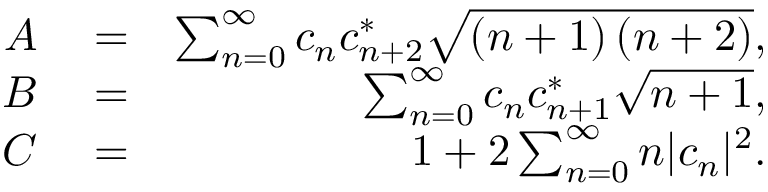<formula> <loc_0><loc_0><loc_500><loc_500>\begin{array} { r l r } { A } & = } & { \sum _ { n = 0 } ^ { \infty } c _ { n } c _ { n + 2 } ^ { * } \sqrt { \left ( n + 1 \right ) \left ( n + 2 \right ) } , } \\ { B } & = } & { \sum _ { n = 0 } ^ { \infty } c _ { n } c _ { n + 1 } ^ { * } \sqrt { n + 1 } , } \\ { C } & = } & { 1 + 2 \sum _ { n = 0 } ^ { \infty } n | c _ { n } | ^ { 2 } . } \end{array}</formula> 